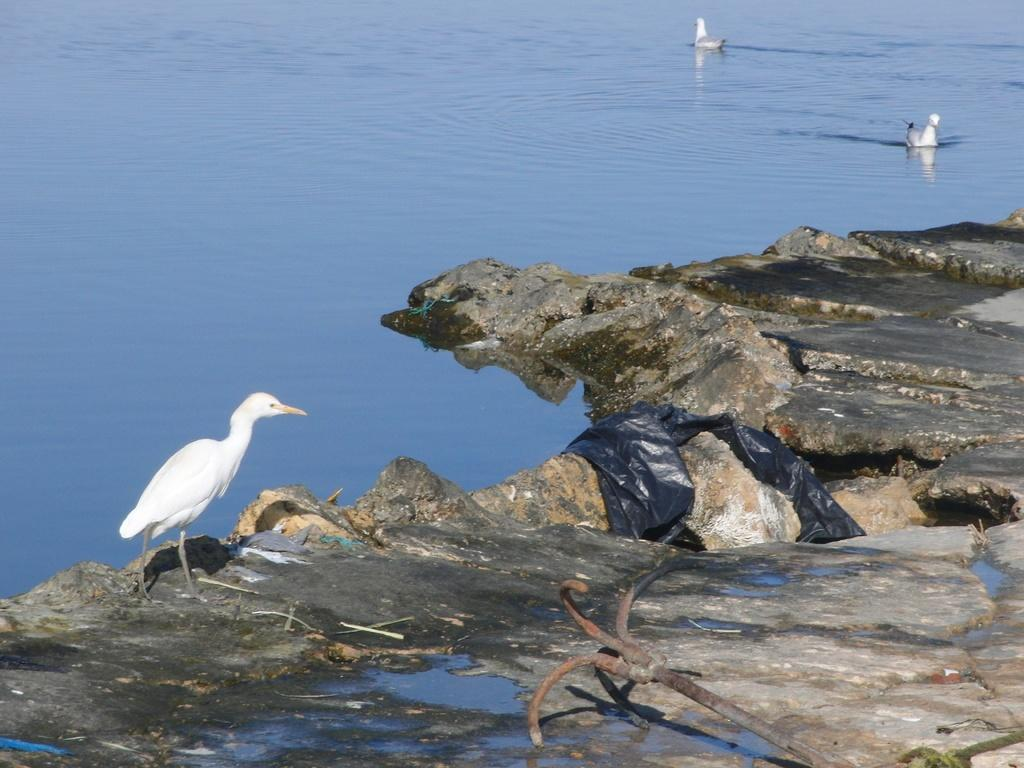What is the main subject of the image? The main subject of the image is a rock. What can be seen near the rock? There is water in the image, and there are objects on the rock. Are there any animals present in the image? Yes, there is a bird on the rock, and there are two birds on the water. What type of flowers can be seen growing on the rock in the image? There are no flowers present on the rock in the image. How does the wheel interact with the harmony of the image? There is no wheel present in the image, so it cannot interact with the harmony of the image. 